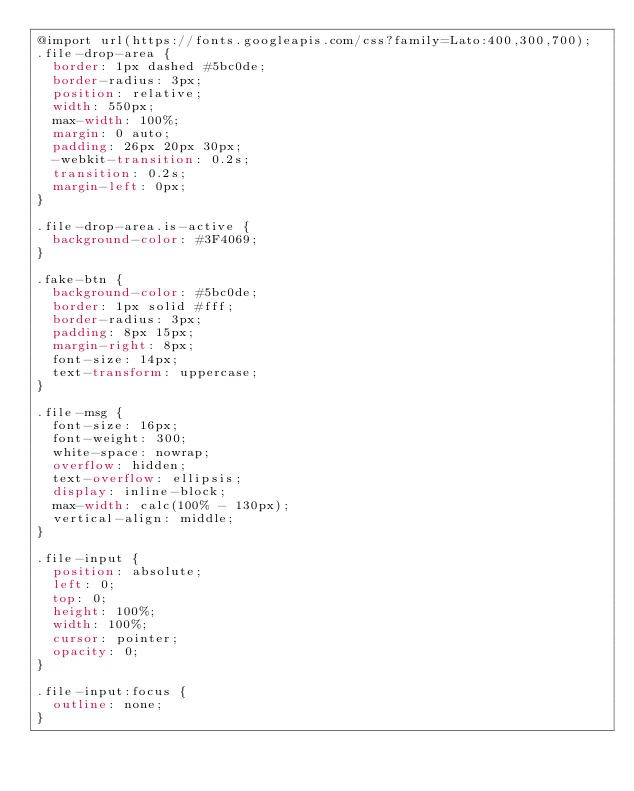Convert code to text. <code><loc_0><loc_0><loc_500><loc_500><_CSS_>@import url(https://fonts.googleapis.com/css?family=Lato:400,300,700);
.file-drop-area {
  border: 1px dashed #5bc0de;
  border-radius: 3px;
  position: relative;
  width: 550px;
  max-width: 100%;
  margin: 0 auto;
  padding: 26px 20px 30px;
  -webkit-transition: 0.2s;
  transition: 0.2s;
  margin-left: 0px;
}

.file-drop-area.is-active {
  background-color: #3F4069;
}

.fake-btn {
  background-color: #5bc0de;
  border: 1px solid #fff;
  border-radius: 3px;
  padding: 8px 15px;
  margin-right: 8px;
  font-size: 14px;
  text-transform: uppercase;
}

.file-msg {
  font-size: 16px;
  font-weight: 300;
  white-space: nowrap;
  overflow: hidden;
  text-overflow: ellipsis;
  display: inline-block;
  max-width: calc(100% - 130px);
  vertical-align: middle;
}

.file-input {
  position: absolute;
  left: 0;
  top: 0;
  height: 100%;
  width: 100%;
  cursor: pointer;
  opacity: 0;
}

.file-input:focus {
  outline: none;
}
</code> 